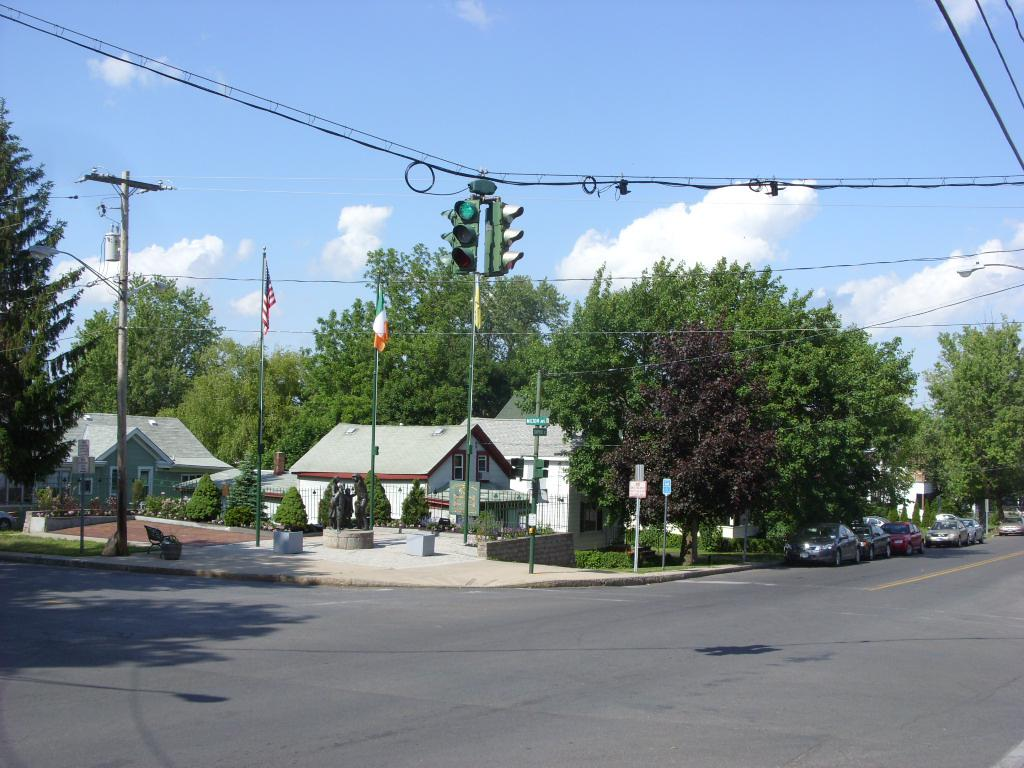Question: when is the photo taken?
Choices:
A. Day time.
B. Night.
C. Afternoon.
D. Morning.
Answer with the letter. Answer: A Question: who is in the photo?
Choices:
A. Two boys.
B. The man and woman.
C. The musician.
D. No one.
Answer with the letter. Answer: D Question: how many people are there?
Choices:
A. 1.
B. 2.
C. None.
D. 3.
Answer with the letter. Answer: C Question: what color is the traffic light?
Choices:
A. Red.
B. Yellow.
C. Green.
D. Orange.
Answer with the letter. Answer: C Question: what color is the road?
Choices:
A. Black.
B. Grey.
C. Brown.
D. Yellow.
Answer with the letter. Answer: B Question: what is next to the american flag?
Choices:
A. A pole.
B. Another flag.
C. An italian flag.
D. A California flag.
Answer with the letter. Answer: B Question: how are the cars arranged?
Choices:
A. In a circle.
B. They are parked.
C. In a row.
D. Side-by-side.
Answer with the letter. Answer: B Question: where are the cars parked?
Choices:
A. On the lawn.
B. In the parking lot.
C. On the ice.
D. On the street.
Answer with the letter. Answer: D Question: what color is the traffic light?
Choices:
A. Red.
B. Yellow.
C. Orange.
D. Green.
Answer with the letter. Answer: D Question: how many trees are there with purple leaves?
Choices:
A. Two.
B. Three.
C. One tree with purple leaves.
D. Four.
Answer with the letter. Answer: C Question: what is the sun doing?
Choices:
A. The sun is setting.
B. The sun is rising.
C. The sun is shining.
D. The sun is eclipsing.
Answer with the letter. Answer: C Question: what are the trees doing?
Choices:
A. Nesting birds.
B. Wilting.
C. Dropping leaves.
D. The trees are casting shadows on the street.
Answer with the letter. Answer: D Question: what has fluffy white clouds?
Choices:
A. The sky.
B. The ground.
C. The mountain.
D. The grass.
Answer with the letter. Answer: A Question: where is flag pole?
Choices:
A. In park across street.
B. In the field.
C. In the parking lot.
D. In the school.
Answer with the letter. Answer: A Question: how many cars coming down the street?
Choices:
A. One.
B. Two.
C. Three.
D. None.
Answer with the letter. Answer: D 